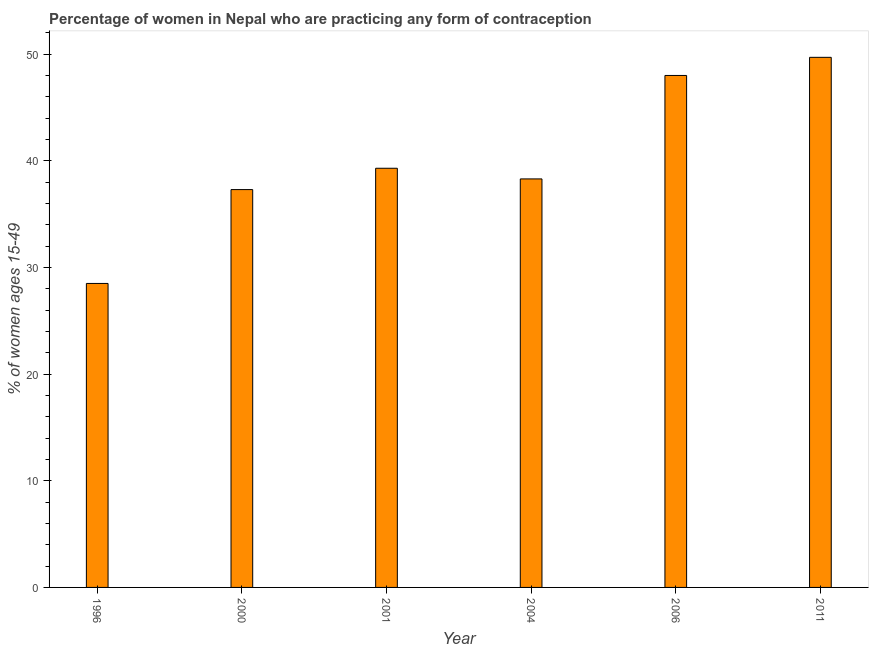Does the graph contain any zero values?
Ensure brevity in your answer.  No. What is the title of the graph?
Your response must be concise. Percentage of women in Nepal who are practicing any form of contraception. What is the label or title of the Y-axis?
Your answer should be very brief. % of women ages 15-49. What is the contraceptive prevalence in 2000?
Your answer should be very brief. 37.3. Across all years, what is the maximum contraceptive prevalence?
Keep it short and to the point. 49.7. Across all years, what is the minimum contraceptive prevalence?
Make the answer very short. 28.5. In which year was the contraceptive prevalence maximum?
Offer a very short reply. 2011. What is the sum of the contraceptive prevalence?
Provide a short and direct response. 241.1. What is the difference between the contraceptive prevalence in 2004 and 2006?
Keep it short and to the point. -9.7. What is the average contraceptive prevalence per year?
Ensure brevity in your answer.  40.18. What is the median contraceptive prevalence?
Your answer should be compact. 38.8. In how many years, is the contraceptive prevalence greater than 14 %?
Your response must be concise. 6. Do a majority of the years between 2011 and 2006 (inclusive) have contraceptive prevalence greater than 10 %?
Offer a terse response. No. What is the ratio of the contraceptive prevalence in 1996 to that in 2001?
Give a very brief answer. 0.72. Is the difference between the contraceptive prevalence in 1996 and 2004 greater than the difference between any two years?
Keep it short and to the point. No. What is the difference between the highest and the lowest contraceptive prevalence?
Provide a succinct answer. 21.2. How many years are there in the graph?
Give a very brief answer. 6. Are the values on the major ticks of Y-axis written in scientific E-notation?
Your answer should be compact. No. What is the % of women ages 15-49 in 1996?
Offer a terse response. 28.5. What is the % of women ages 15-49 in 2000?
Your answer should be compact. 37.3. What is the % of women ages 15-49 in 2001?
Give a very brief answer. 39.3. What is the % of women ages 15-49 in 2004?
Offer a very short reply. 38.3. What is the % of women ages 15-49 in 2011?
Your response must be concise. 49.7. What is the difference between the % of women ages 15-49 in 1996 and 2004?
Offer a terse response. -9.8. What is the difference between the % of women ages 15-49 in 1996 and 2006?
Provide a succinct answer. -19.5. What is the difference between the % of women ages 15-49 in 1996 and 2011?
Ensure brevity in your answer.  -21.2. What is the difference between the % of women ages 15-49 in 2000 and 2001?
Ensure brevity in your answer.  -2. What is the difference between the % of women ages 15-49 in 2000 and 2006?
Give a very brief answer. -10.7. What is the difference between the % of women ages 15-49 in 2001 and 2006?
Your response must be concise. -8.7. What is the difference between the % of women ages 15-49 in 2001 and 2011?
Make the answer very short. -10.4. What is the difference between the % of women ages 15-49 in 2004 and 2011?
Give a very brief answer. -11.4. What is the difference between the % of women ages 15-49 in 2006 and 2011?
Make the answer very short. -1.7. What is the ratio of the % of women ages 15-49 in 1996 to that in 2000?
Your answer should be very brief. 0.76. What is the ratio of the % of women ages 15-49 in 1996 to that in 2001?
Offer a terse response. 0.72. What is the ratio of the % of women ages 15-49 in 1996 to that in 2004?
Keep it short and to the point. 0.74. What is the ratio of the % of women ages 15-49 in 1996 to that in 2006?
Offer a very short reply. 0.59. What is the ratio of the % of women ages 15-49 in 1996 to that in 2011?
Your answer should be very brief. 0.57. What is the ratio of the % of women ages 15-49 in 2000 to that in 2001?
Ensure brevity in your answer.  0.95. What is the ratio of the % of women ages 15-49 in 2000 to that in 2006?
Your answer should be compact. 0.78. What is the ratio of the % of women ages 15-49 in 2000 to that in 2011?
Your response must be concise. 0.75. What is the ratio of the % of women ages 15-49 in 2001 to that in 2006?
Ensure brevity in your answer.  0.82. What is the ratio of the % of women ages 15-49 in 2001 to that in 2011?
Provide a succinct answer. 0.79. What is the ratio of the % of women ages 15-49 in 2004 to that in 2006?
Your answer should be very brief. 0.8. What is the ratio of the % of women ages 15-49 in 2004 to that in 2011?
Your answer should be very brief. 0.77. 